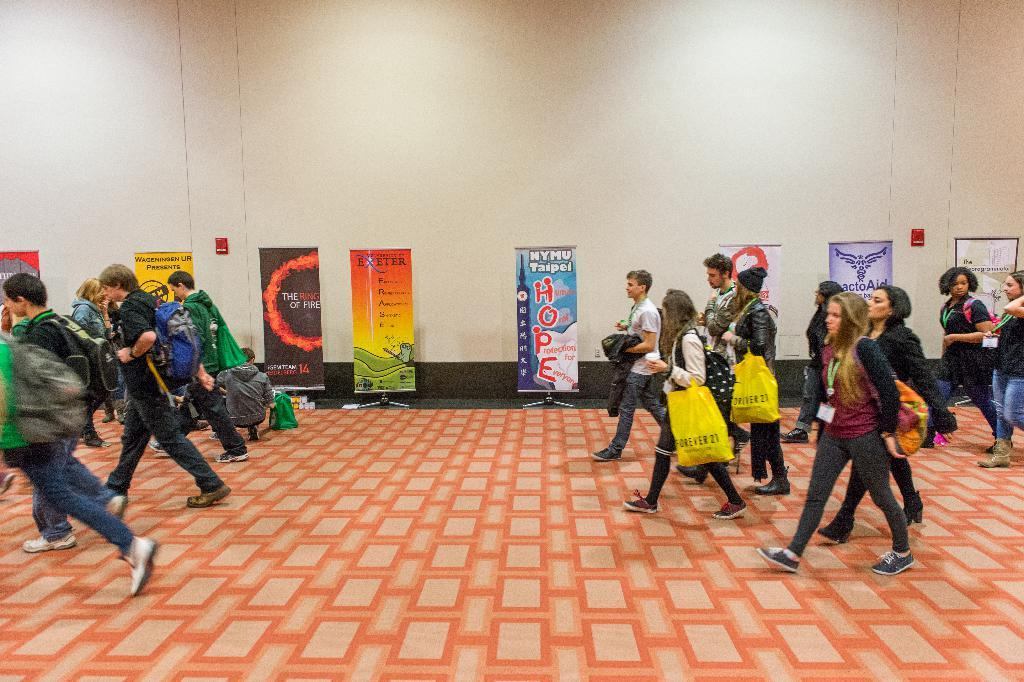What are the people in the image doing? The people in the image are walking in the center of the image. On what surface are the people walking? The people are walking on the floor. What can be seen in the background of the image? There is a wall and advertisement banners in the background of the image. Can you see any cows grazing in the cemetery in the image? There is no cemetery or cow present in the image. 